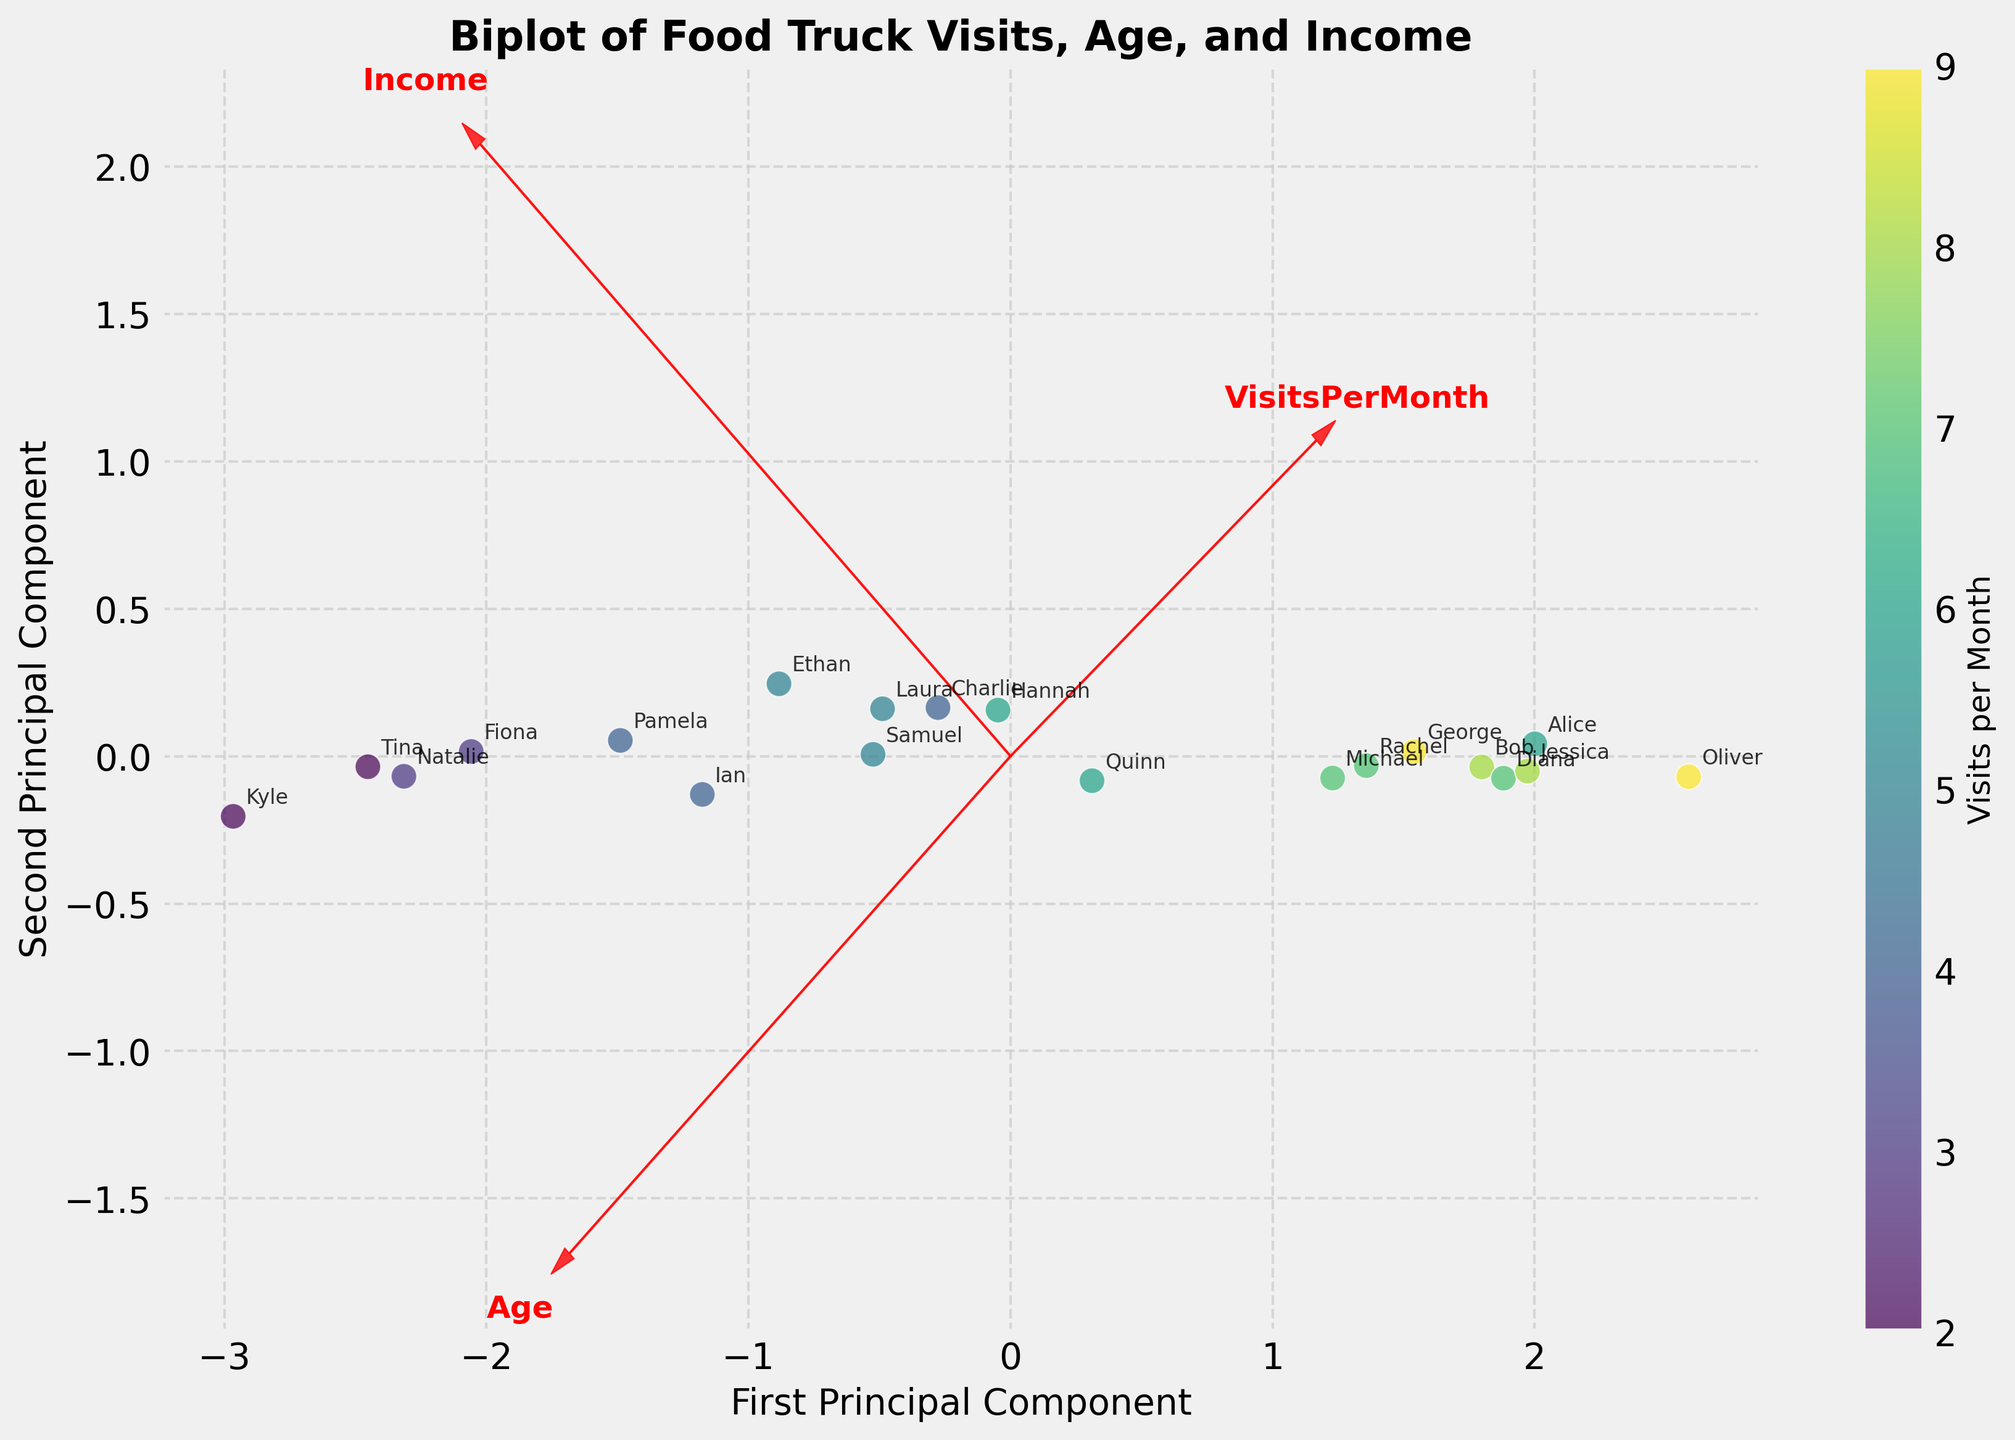What is the title of the figure? The title of the figure is typically located at the top and it's displayed in bold font. From the given code, the title is set to 'Biplot of Food Truck Visits, Age, and Income'.
Answer: Biplot of Food Truck Visits, Age, and Income How many club members' data points are displayed in the plot? Each club member has one corresponding data point on the scatter plot. From the data provided, there are 20 unique club members.
Answer: 20 Which club member visits the food truck most frequently? The number of visits per month is depicted via the color intensity of the data points; a darker color indicates more visits. The label beside the darkest-colored point shows that ‘Oliver’ visits the food truck the most frequently.
Answer: Oliver Which principal component axis is associated with 'Age'? The feature vectors are plotted as red arrows, and each is labeled. The position of the 'Age' label near one of these arrows tells which axis 'Age' is associated with.
Answer: First Principal Component Between 'Age' and 'Income', which factor has a stronger influence on 'VisitsPerMonth’ based on the plot? The length of the feature vectors (arrows) indicates the contribution to the variability in the data. Here, the arrow corresponding to 'VisitsPerMonth' is closer to 'Income' than 'Age', showing a stronger influence.
Answer: Income What is the relationship between 'Age' and 'Income' based on the plot? By looking at the directions of the vectors for 'Age' and 'Income', which form an angle, one can infer their relationship. As these vectors point in somewhat similar directions, this indicates a positive correlation between age and income.
Answer: Positive correlation Which club members in their 40s tend to visit the food truck fewer times per month? The data points with darker colors represent fewer visits. Members labeled near points in their 40s (like Fiona, Ian, Pamela, Natalie, and Tina) can be inspected. Ian, Pamela, Natalie, and Tina are the ones in their 40s who visit less frequently.
Answer: Ian, Pamela, Natalie, Tina Is there a club member with a high income but low food truck visits? Club members with high income will be towards the end of the income vector. For low visits, we look for lighter color points. 'Fiona' with an income of $70,000 and 3 visits per month matches this criterion.
Answer: Fiona How does the variability in ‘VisitsPerMonth’ compare with ‘Age’? The direction and spread of the 'VisitsPerMonth' feature vector relative to 'Age' on the plot shows how much each contributes to the principal components. The longer the arrow and more spread out points in the principal component directions, the greater the variability. It appears ‘VisitsPerMonth’ has significant spread.
Answer: More variable Do younger club members generally visit the food truck more often? By observing the data points and annotated labels, we compare the positions of younger members and the color intensity. Many younger individuals like Oliver, Rachel, and Diana, have relatively more frequent visits suggesting a trend.
Answer: Yes 